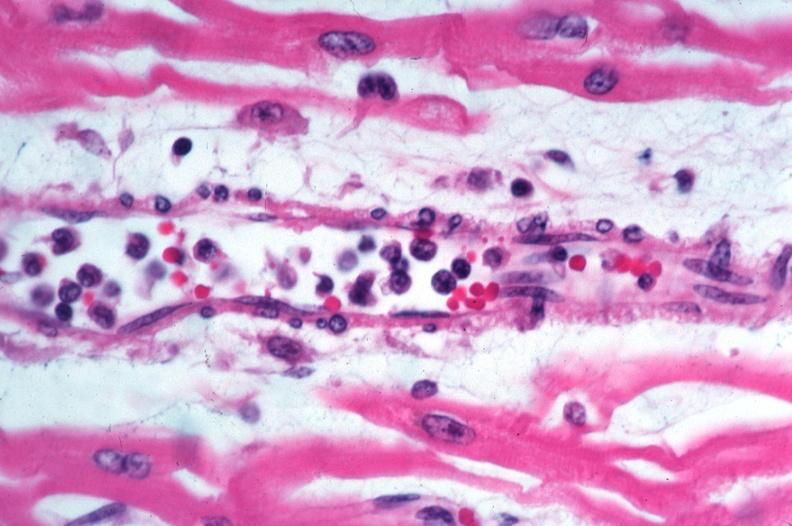does this image shows lung, bronchopneumonia, bacterial, tissue gram show skin?
Answer the question using a single word or phrase. No 